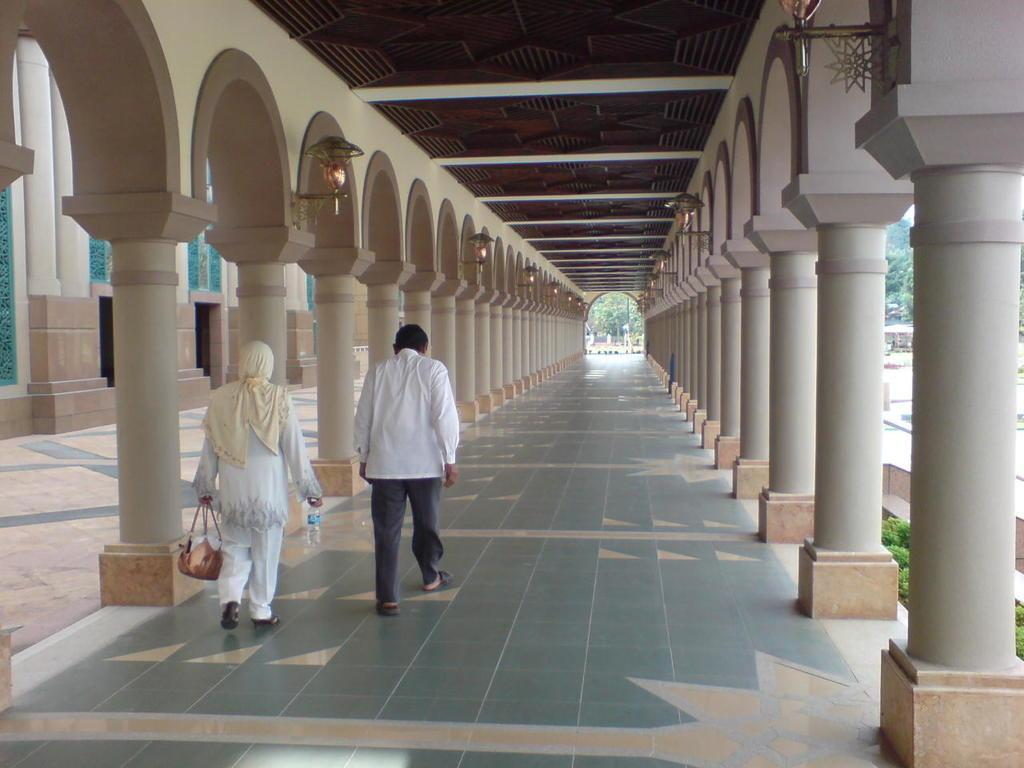How many people are walking in the image? There are two persons walking in the image. What is the surface on which the persons are walking? The persons are walking on the ground. What architectural features can be seen in the image? There are pillars in the image. What type of vegetation is present in front of the persons? There are trees in front of the persons. What type of lighting is present in the image? There is a lamp in the image. What structure is visible at the top of the image? There is a roof visible at the top of the image. How many children are playing in the hole in the image? There is no hole or children present in the image. 